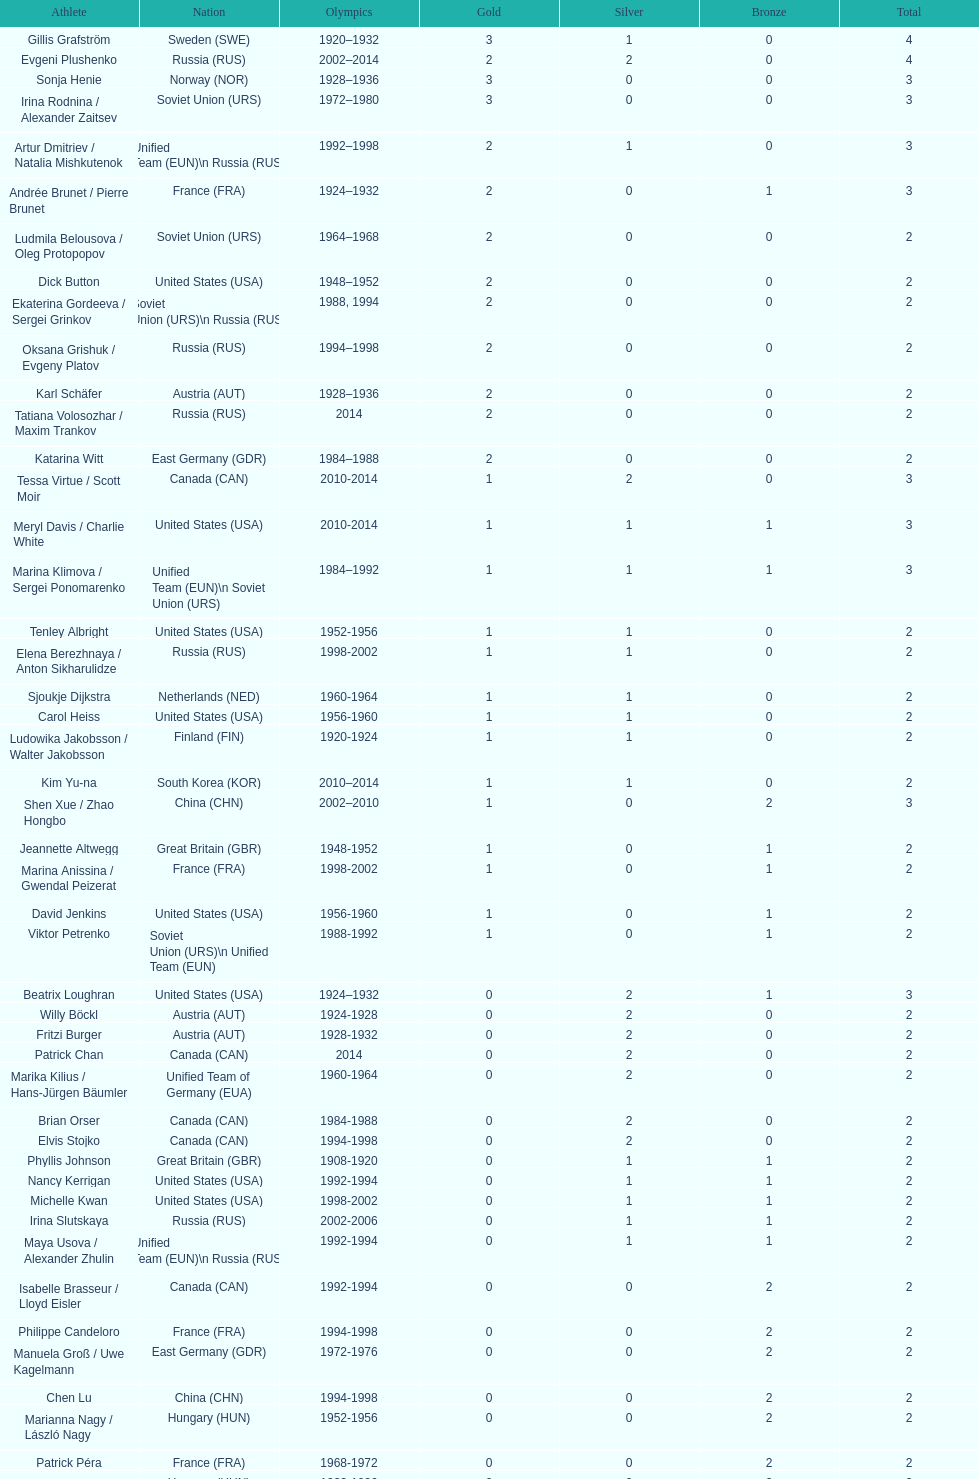Which nation was the first to win three gold medals for olympic figure skating? Sweden. 